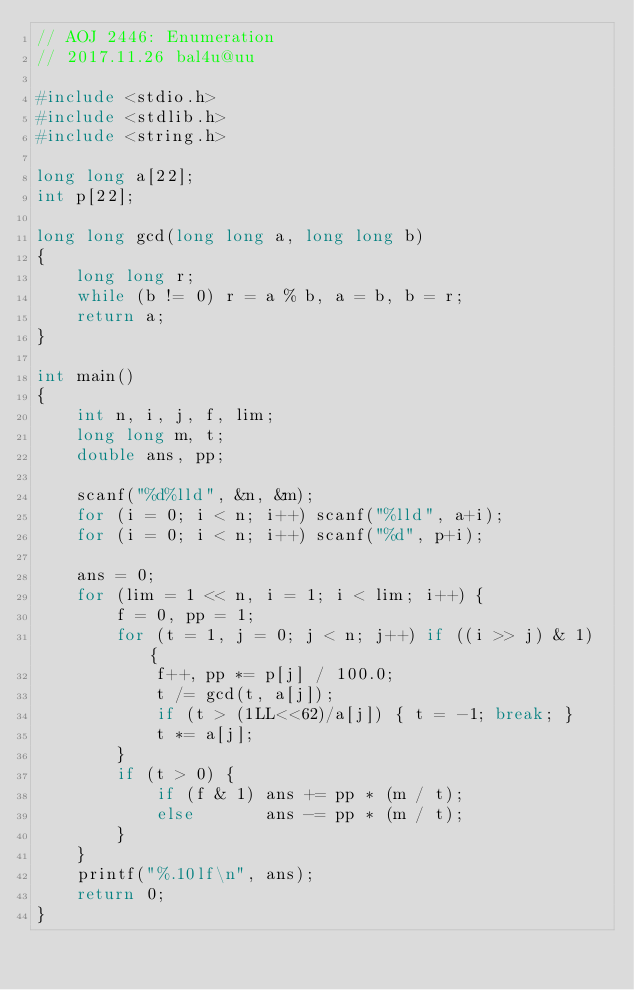Convert code to text. <code><loc_0><loc_0><loc_500><loc_500><_C_>// AOJ 2446: Enumeration
// 2017.11.26 bal4u@uu

#include <stdio.h>
#include <stdlib.h>
#include <string.h>

long long a[22];
int p[22];

long long gcd(long long a, long long b)
{
	long long r;
	while (b != 0) r = a % b, a = b, b = r;
	return a;
}

int main()
{
	int n, i, j, f, lim;
	long long m, t;
	double ans, pp;

	scanf("%d%lld", &n, &m);
	for (i = 0; i < n; i++) scanf("%lld", a+i);
	for (i = 0; i < n; i++) scanf("%d", p+i);
	
	ans = 0;
	for (lim = 1 << n, i = 1; i < lim; i++) {
		f = 0, pp = 1;
		for (t = 1, j = 0; j < n; j++) if ((i >> j) & 1) {
			f++, pp *= p[j] / 100.0;
			t /= gcd(t, a[j]);
			if (t > (1LL<<62)/a[j]) { t = -1; break; }
			t *= a[j];
		}
		if (t > 0) {
			if (f & 1) ans += pp * (m / t);
			else       ans -= pp * (m / t);
		}
	}
	printf("%.10lf\n", ans);
	return 0;
}</code> 